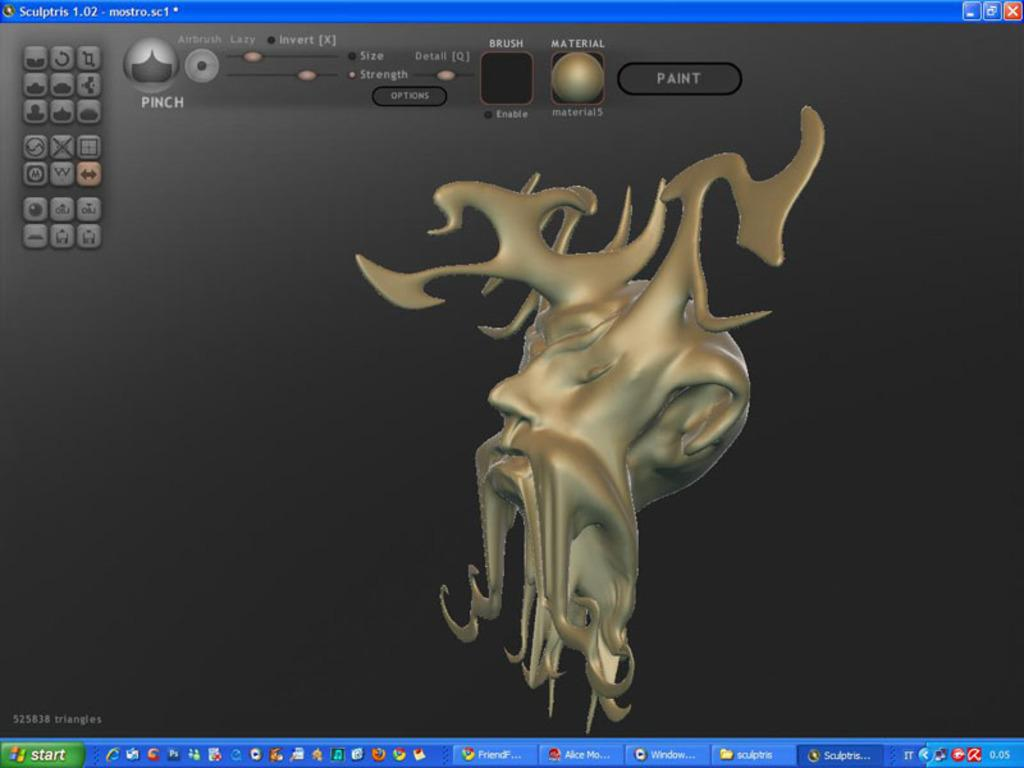<image>
Share a concise interpretation of the image provided. an open window of sculptris with an in progress texture. 